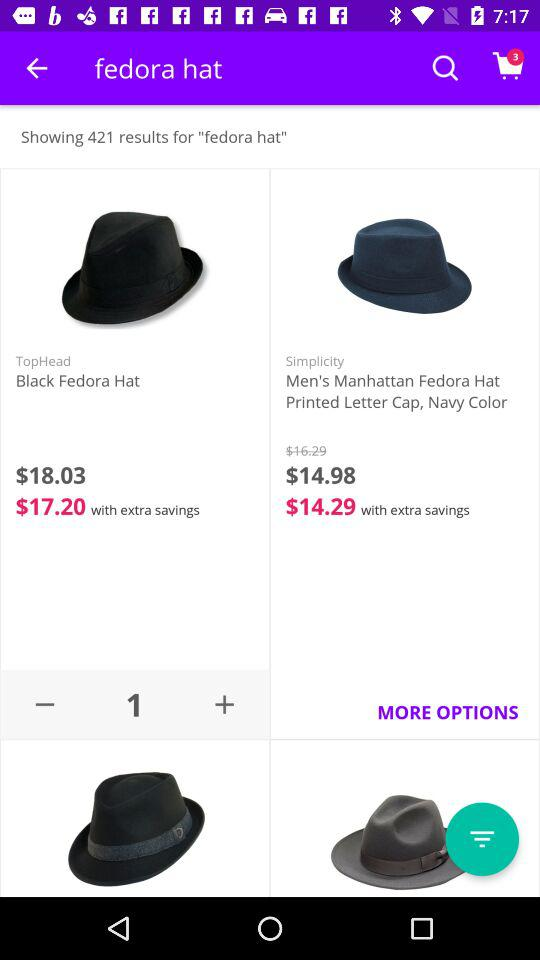How many results are shown for "fedora hat"? There are 421 results shown for "fedora hat". 